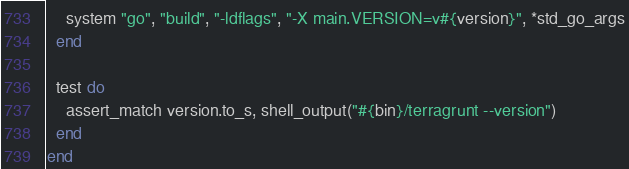<code> <loc_0><loc_0><loc_500><loc_500><_Ruby_>    system "go", "build", "-ldflags", "-X main.VERSION=v#{version}", *std_go_args
  end

  test do
    assert_match version.to_s, shell_output("#{bin}/terragrunt --version")
  end
end
</code> 